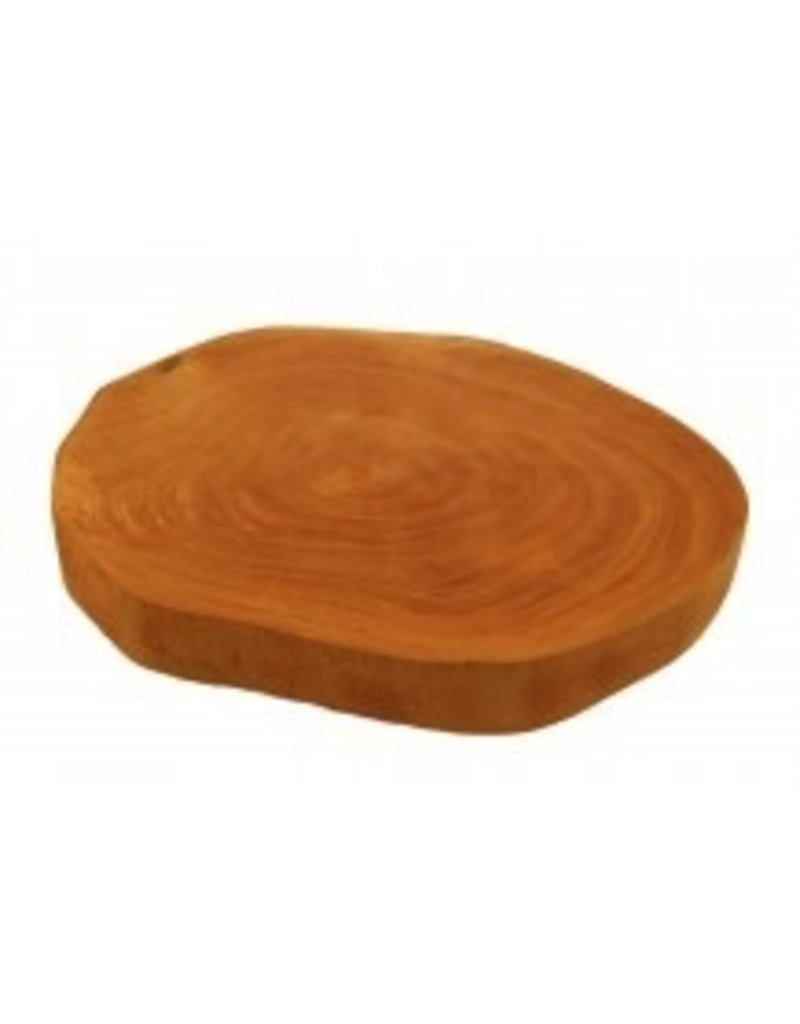Based on the growth rings visible on the wooden slab, what can be inferred about the environmental conditions during the life of the tree from which this slab was cut? The growth rings on the wooden slab are varied in thickness. Generally, wider rings indicate years of favorable growth conditions, such as good weather, adequate rainfall, and optimal temperatures, while narrower rings suggest years of harsher conditions like drought or cold. The presence of both wide and narrow rings on this slab suggests that the tree experienced fluctuations in environmental conditions throughout its life. However, without more specific information on the tree species or the region where it grew, only a general inference can be made about the environmental history reflected in the growth rings. 